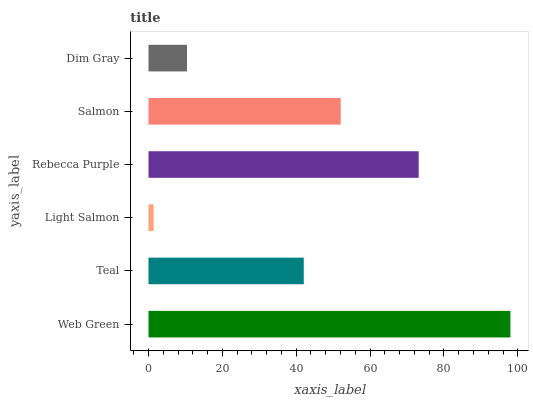Is Light Salmon the minimum?
Answer yes or no. Yes. Is Web Green the maximum?
Answer yes or no. Yes. Is Teal the minimum?
Answer yes or no. No. Is Teal the maximum?
Answer yes or no. No. Is Web Green greater than Teal?
Answer yes or no. Yes. Is Teal less than Web Green?
Answer yes or no. Yes. Is Teal greater than Web Green?
Answer yes or no. No. Is Web Green less than Teal?
Answer yes or no. No. Is Salmon the high median?
Answer yes or no. Yes. Is Teal the low median?
Answer yes or no. Yes. Is Web Green the high median?
Answer yes or no. No. Is Light Salmon the low median?
Answer yes or no. No. 